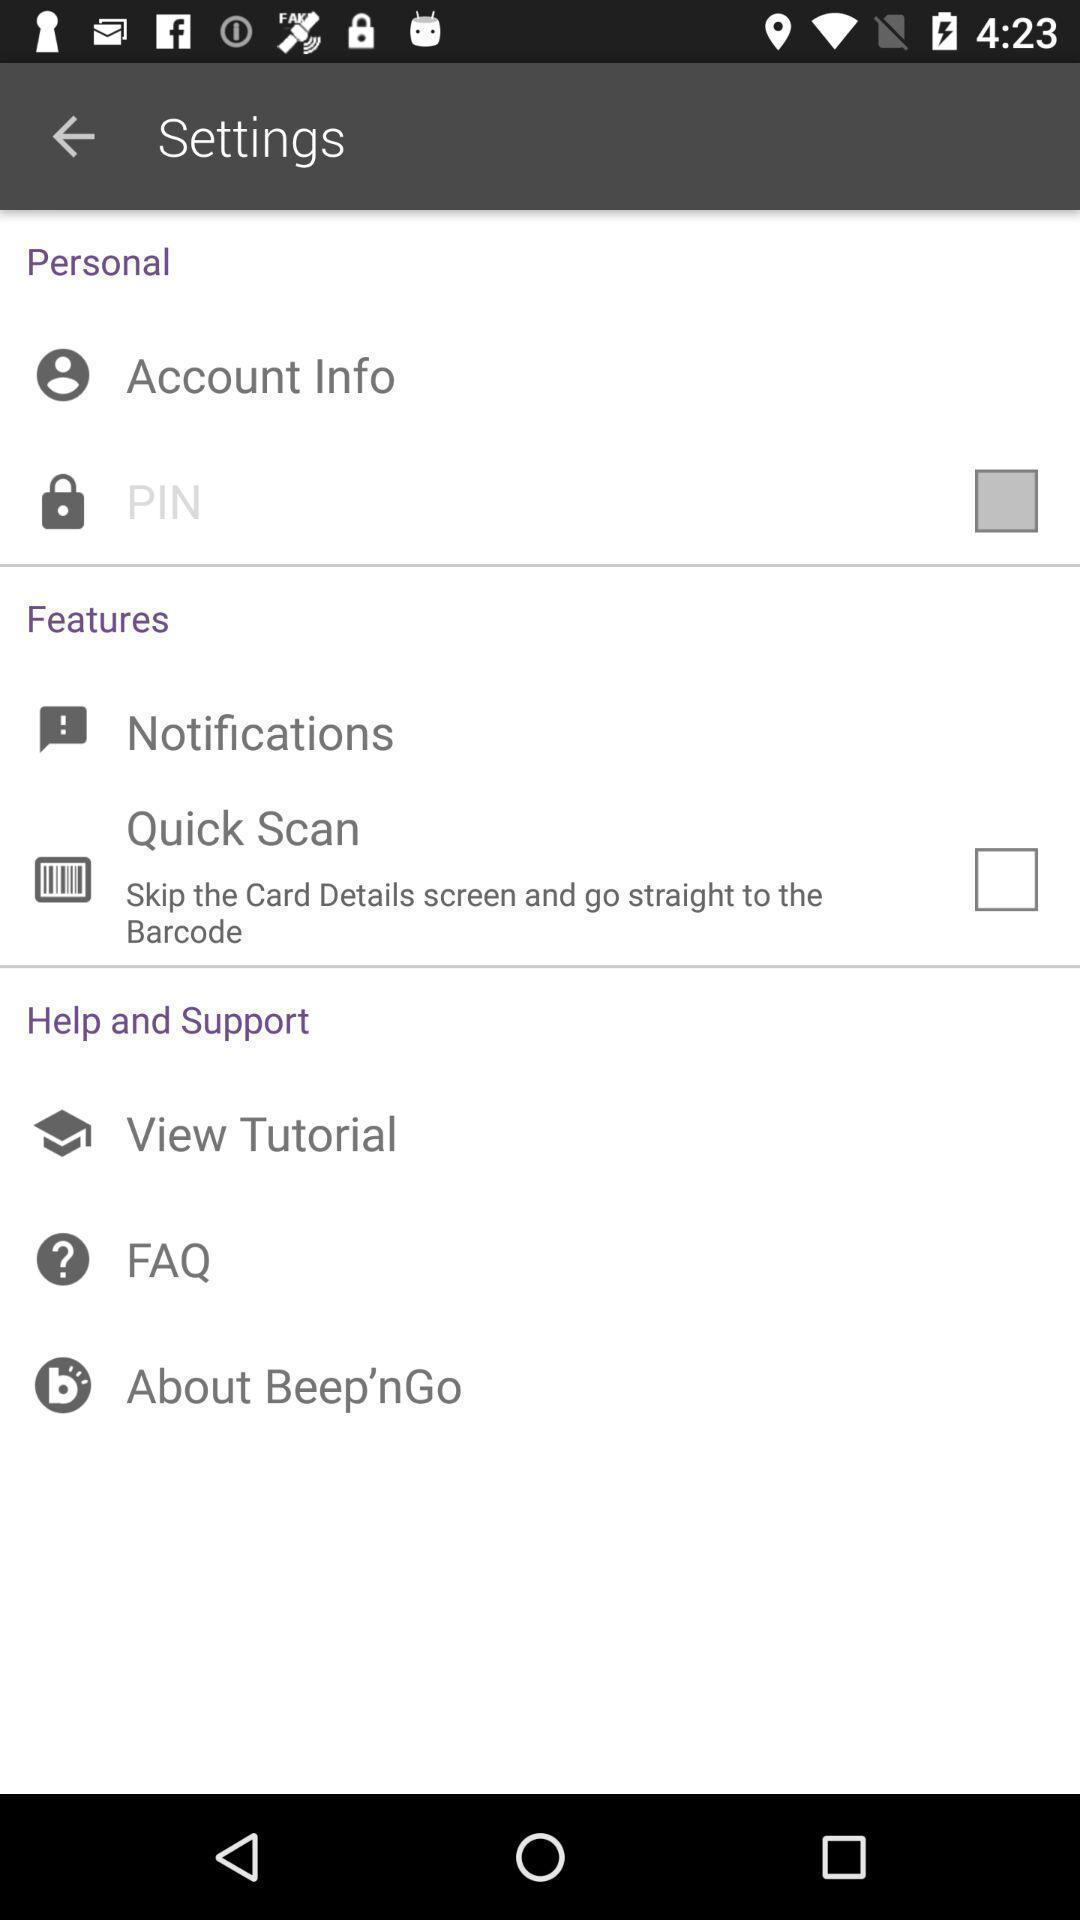What can you discern from this picture? Settings page with various options. 